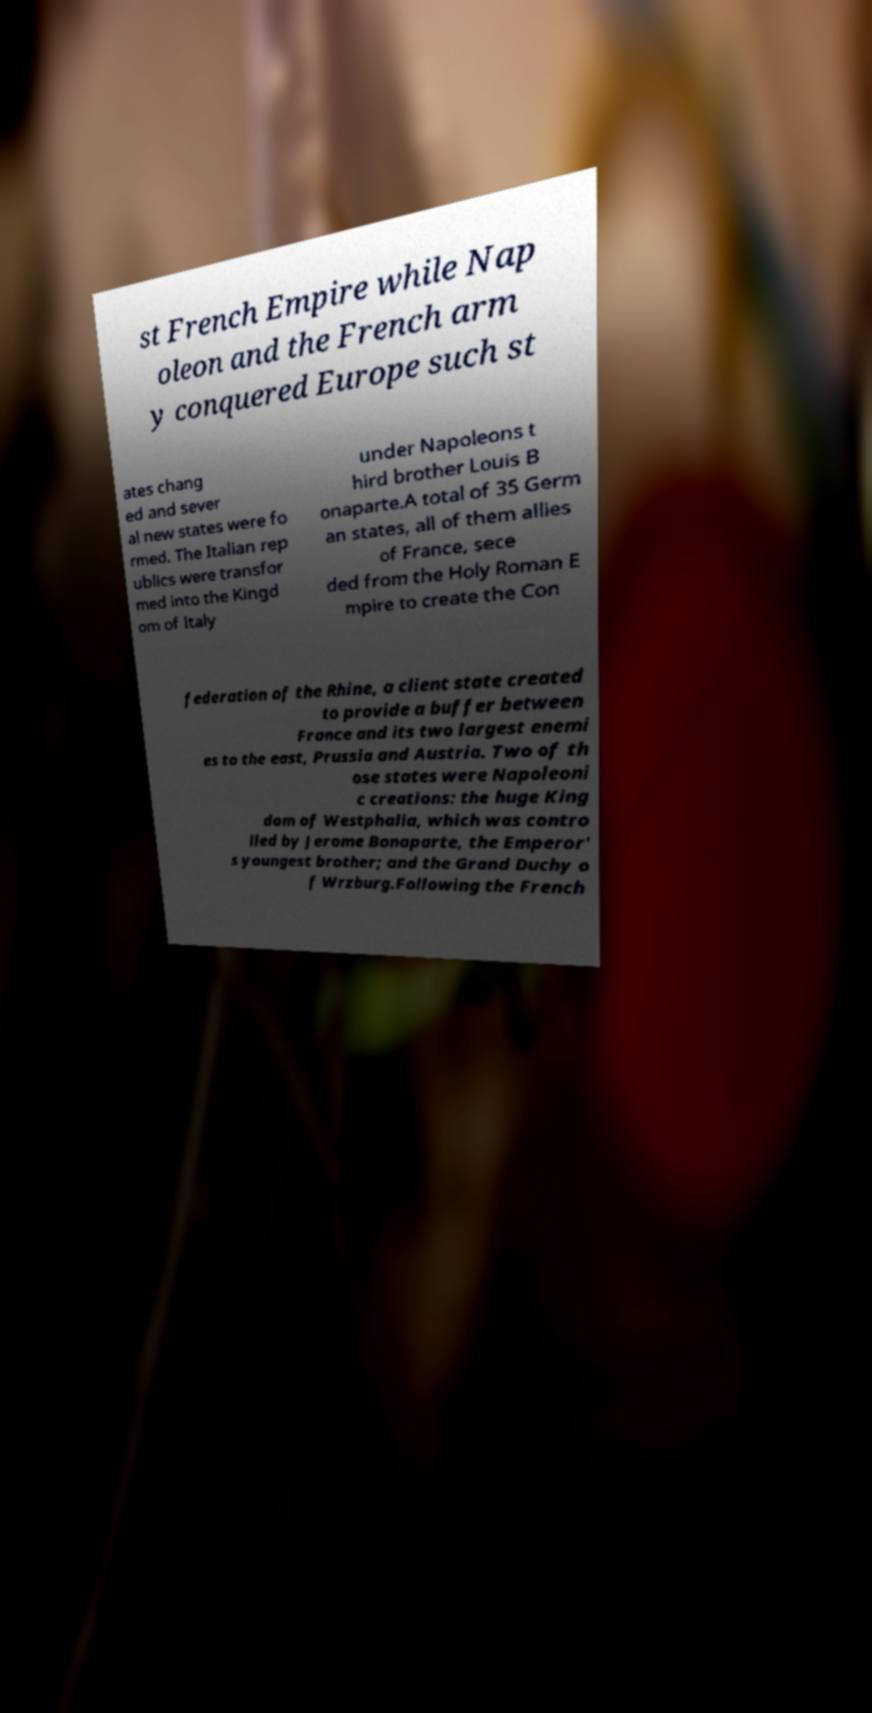Please read and relay the text visible in this image. What does it say? st French Empire while Nap oleon and the French arm y conquered Europe such st ates chang ed and sever al new states were fo rmed. The Italian rep ublics were transfor med into the Kingd om of Italy under Napoleons t hird brother Louis B onaparte.A total of 35 Germ an states, all of them allies of France, sece ded from the Holy Roman E mpire to create the Con federation of the Rhine, a client state created to provide a buffer between France and its two largest enemi es to the east, Prussia and Austria. Two of th ose states were Napoleoni c creations: the huge King dom of Westphalia, which was contro lled by Jerome Bonaparte, the Emperor' s youngest brother; and the Grand Duchy o f Wrzburg.Following the French 